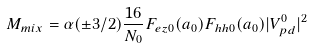Convert formula to latex. <formula><loc_0><loc_0><loc_500><loc_500>M _ { m i x } = \alpha ( \pm 3 / 2 ) \frac { 1 6 } { N _ { 0 } } F _ { e z 0 } ( { a } _ { 0 } ) F _ { h h 0 } ( { a } _ { 0 } ) | V ^ { 0 } _ { p d } | ^ { 2 }</formula> 